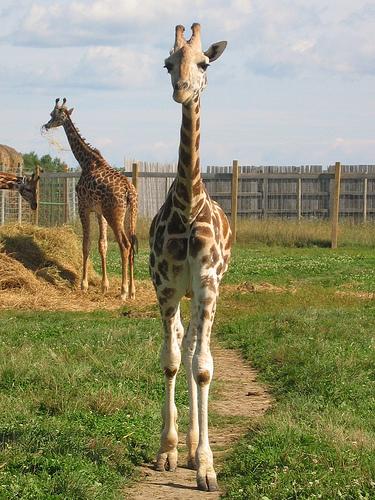How many giraffes?
Write a very short answer. 3. How tall do you think these giraffes are?
Short answer required. 8 feet. What kind of animal is shown?
Be succinct. Giraffe. 